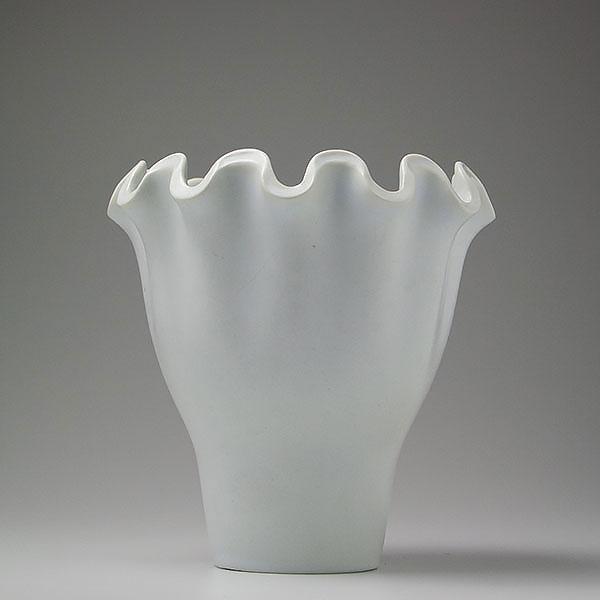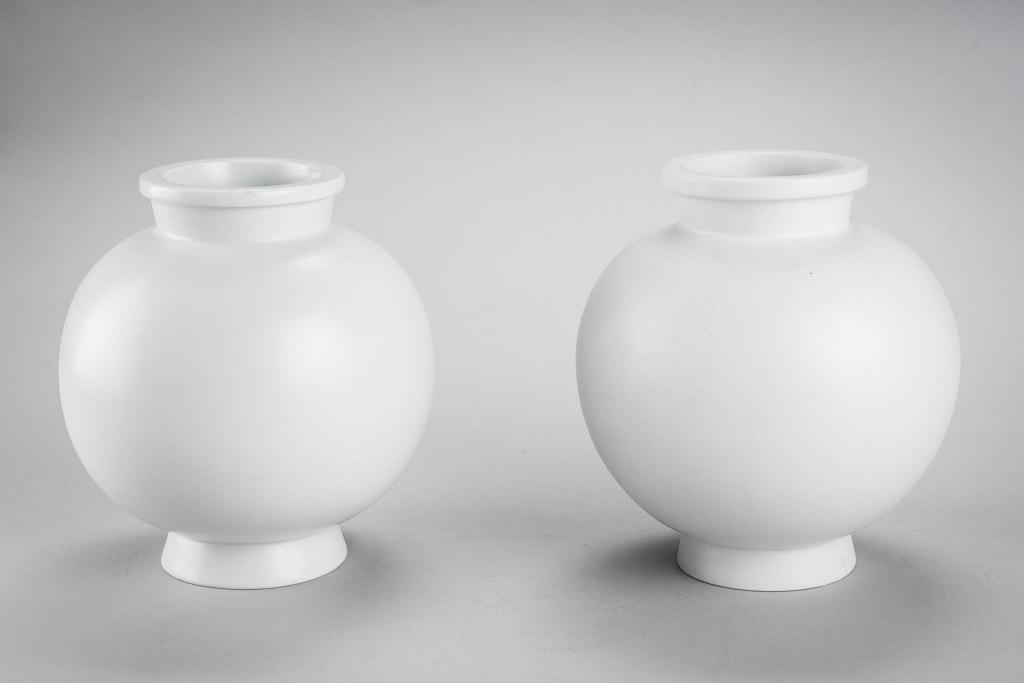The first image is the image on the left, the second image is the image on the right. Given the left and right images, does the statement "One image has two vases of equal height." hold true? Answer yes or no. Yes. The first image is the image on the left, the second image is the image on the right. For the images displayed, is the sentence "there are no more than 3 vases in an image pair" factually correct? Answer yes or no. Yes. 